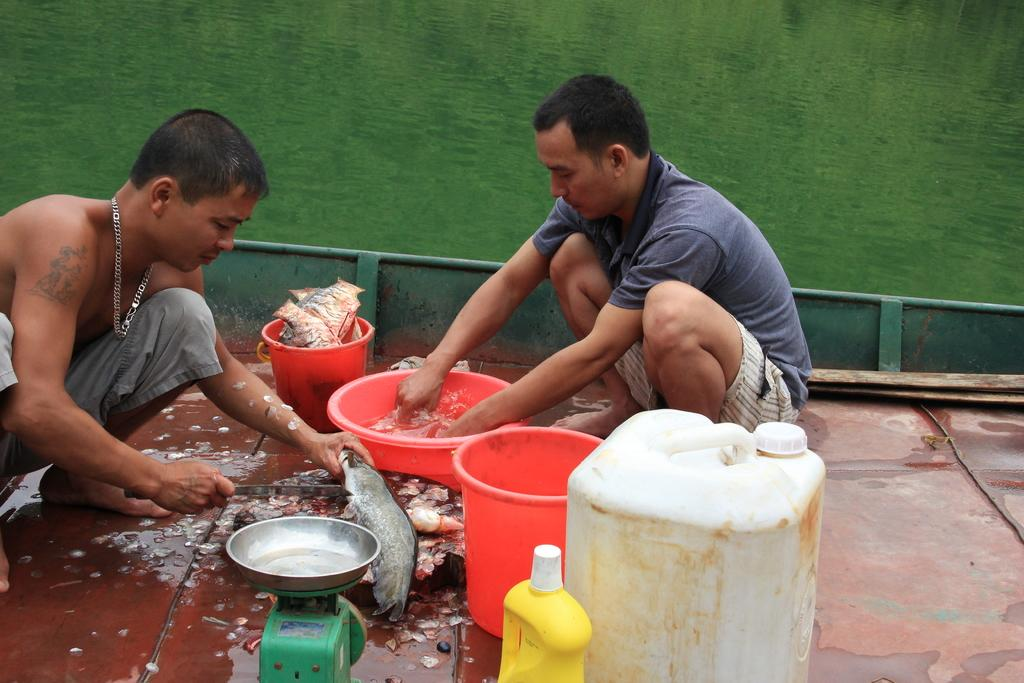How many people are sitting on the floor in the image? There are two persons sitting on the floor in the image. What are the persons doing while sitting on the floor? The persons are washing dishes. What device can be seen in the image that is used for measuring weight? There is a weighing machine in the image. What type of food is present in the image? There are fish in the image. What type of container is present in the image? There are buckets in the image. What type of waste container is present in the image? There is a bin in the image. How many girls are present in the image? There is no mention of girls in the image. 